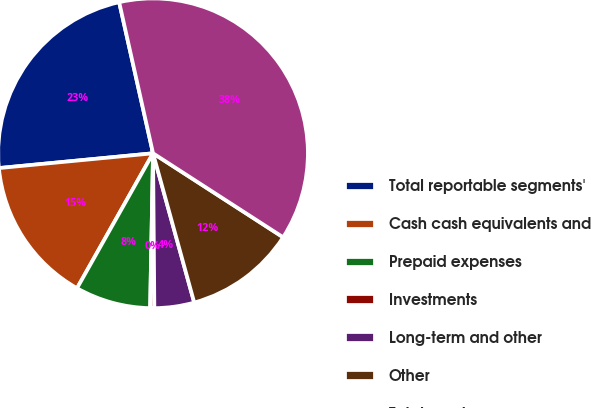<chart> <loc_0><loc_0><loc_500><loc_500><pie_chart><fcel>Total reportable segments'<fcel>Cash cash equivalents and<fcel>Prepaid expenses<fcel>Investments<fcel>Long-term and other<fcel>Other<fcel>Total assets<nl><fcel>23.01%<fcel>15.31%<fcel>7.87%<fcel>0.43%<fcel>4.15%<fcel>11.59%<fcel>37.63%<nl></chart> 